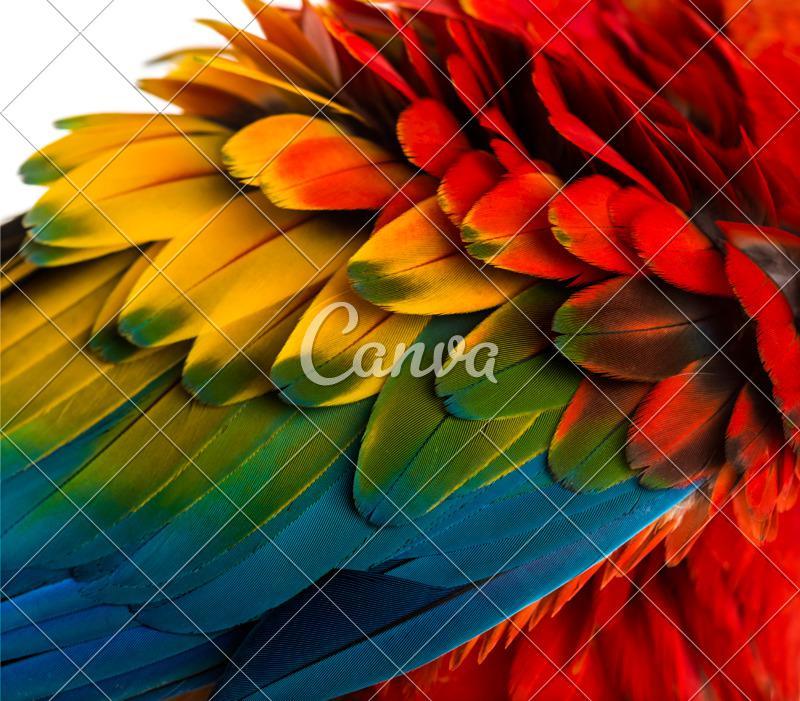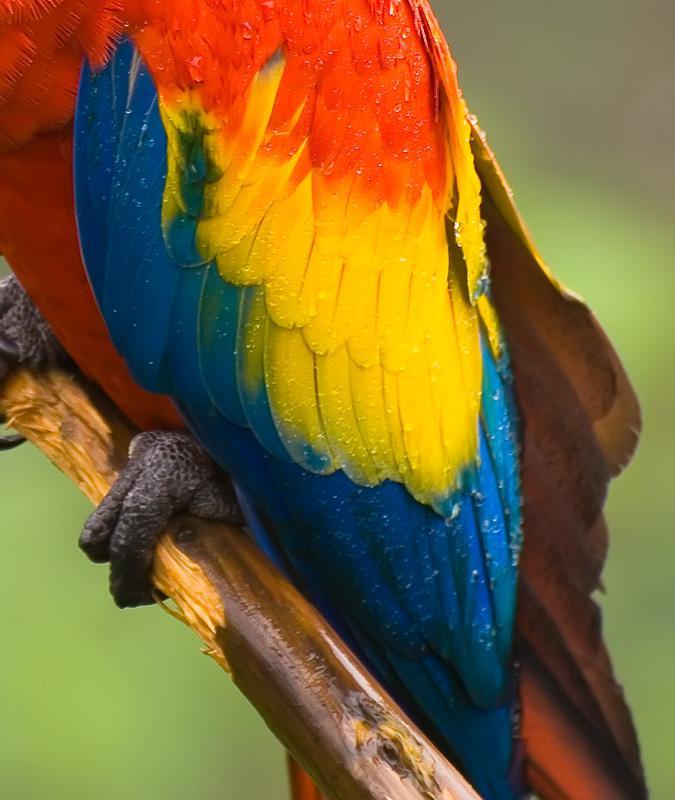The first image is the image on the left, the second image is the image on the right. Considering the images on both sides, is "You can see a Macaw's beak in the left image." valid? Answer yes or no. No. 